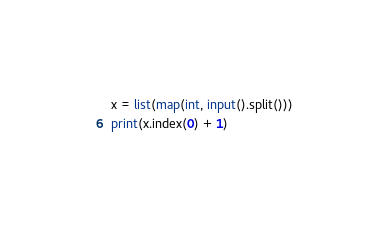Convert code to text. <code><loc_0><loc_0><loc_500><loc_500><_Python_>x = list(map(int, input().split()))
print(x.index(0) + 1)
</code> 